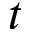Convert formula to latex. <formula><loc_0><loc_0><loc_500><loc_500>t</formula> 